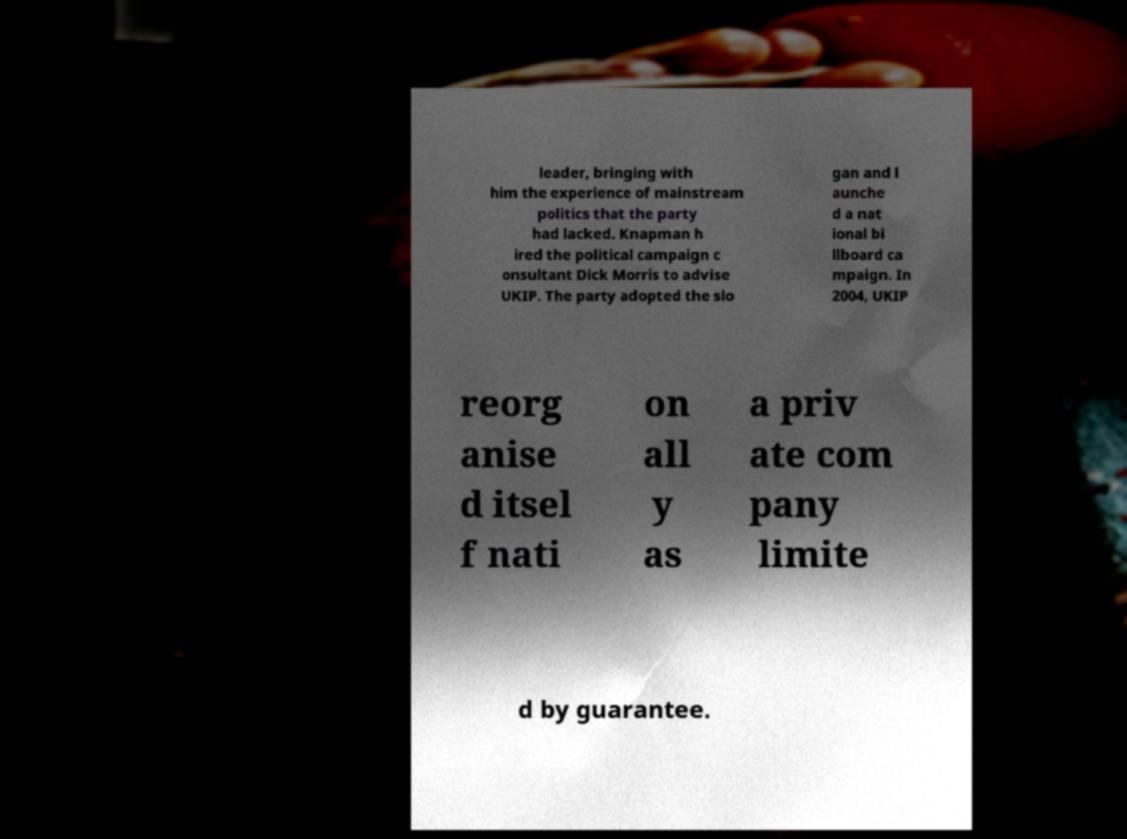Could you extract and type out the text from this image? leader, bringing with him the experience of mainstream politics that the party had lacked. Knapman h ired the political campaign c onsultant Dick Morris to advise UKIP. The party adopted the slo gan and l aunche d a nat ional bi llboard ca mpaign. In 2004, UKIP reorg anise d itsel f nati on all y as a priv ate com pany limite d by guarantee. 